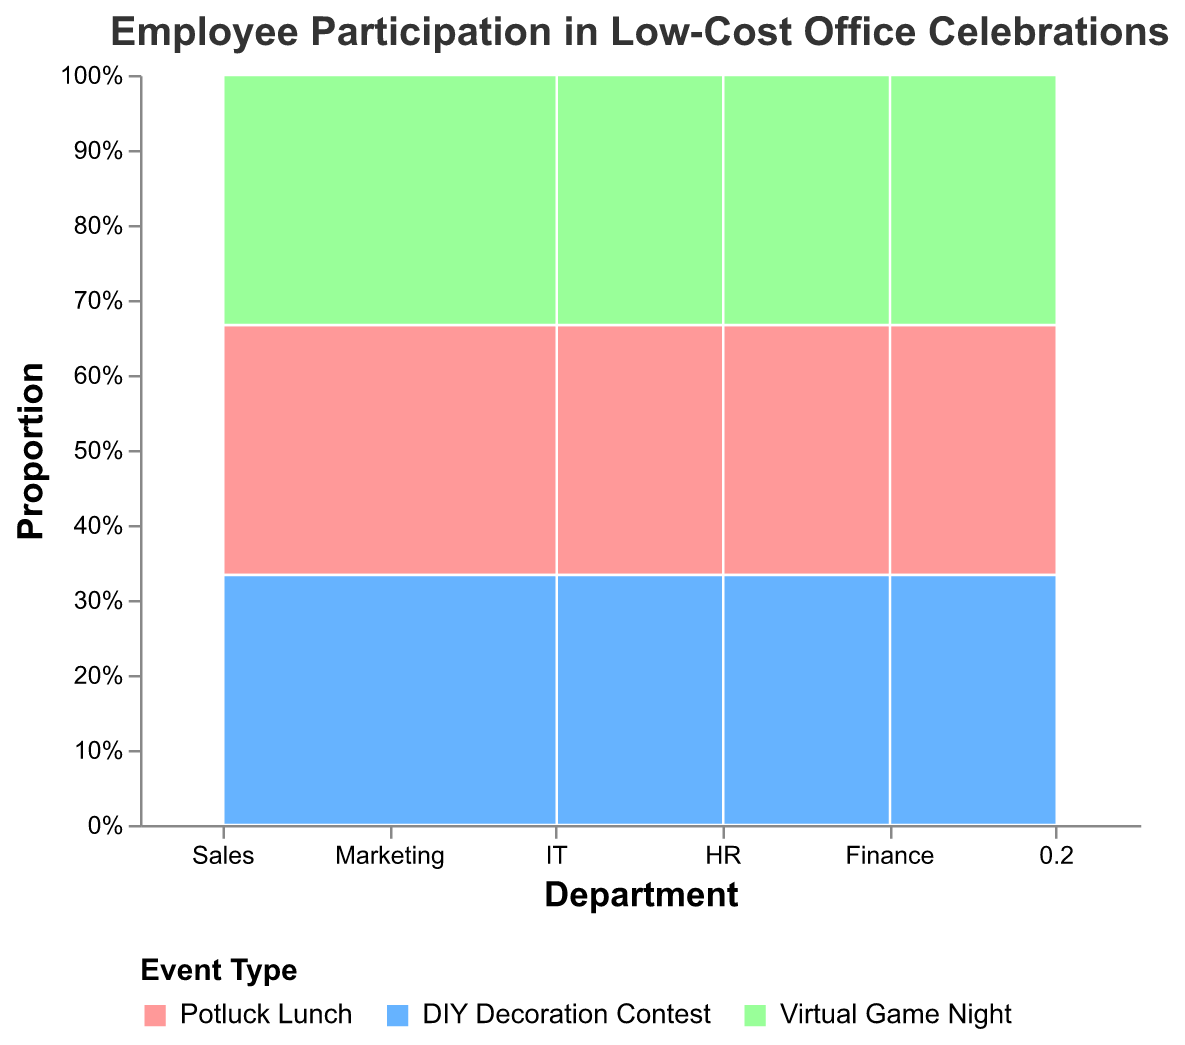What is the title of the plot? The title is located at the top of the plot and indicates what the entire plot represents. The title reads "Employee Participation in Low-Cost Office Celebrations."
Answer: Employee Participation in Low-Cost Office Celebrations Which department had the highest participation in Potluck Lunch? Look at the section for Potluck Lunch and identify the department with the largest proportional area. That would be Sales.
Answer: Sales Which event type had the least participation in the HR department? Focus on the HR department and compare the areas of each event type. The smallest area belongs to "Virtual Game Night".
Answer: Virtual Game Night How does the participation in DIY Decoration Contest compare between IT and Finance departments? Compare the sections corresponding to DIY Decoration Contest for both IT and Finance. The IT section is larger than the Finance section.
Answer: IT has higher participation than Finance What is the total number of participants in the Sales department across all events? Add the participation numbers for all event types within the Sales department. That's 25 (Potluck Lunch) + 20 (DIY Decoration Contest) + 28 (Virtual Game Night).
Answer: 73 Which event type had the highest overall participation and in which department? Look for the largest section across all departments and event types. The largest section is associated with Virtual Game Night in the Sales department.
Answer: Virtual Game Night in Sales Calculate the proportion of participation in Potluck Lunch within the Marketing department out of the total participation in Marketing. The total participation in Marketing is 18 + 15 + 22 = 55. The participation for Potluck Lunch is 18. The proportion is 18/55.
Answer: ~0.327 Compare the participation in Virtual Game Night between Marketing and HR. Which department has the higher participation? Compare the sections corresponding to Virtual Game Night for both Marketing and HR. Marketing has a larger section.
Answer: Marketing has higher participation than HR What is the relative proportion of participation between Potluck Lunch and DIY Decoration Contest in the IT department? The participation in IT for Potluck Lunch is 12, and for DIY Decoration Contest is 16. The relative proportion is 12/16.
Answer: 0.75 Which department shows the least overall participation in all events combined? Add the participation numbers for each event type within each department and identify the smallest total. The department with the smallest total is HR (8 + 10 + 7 = 25).
Answer: HR 